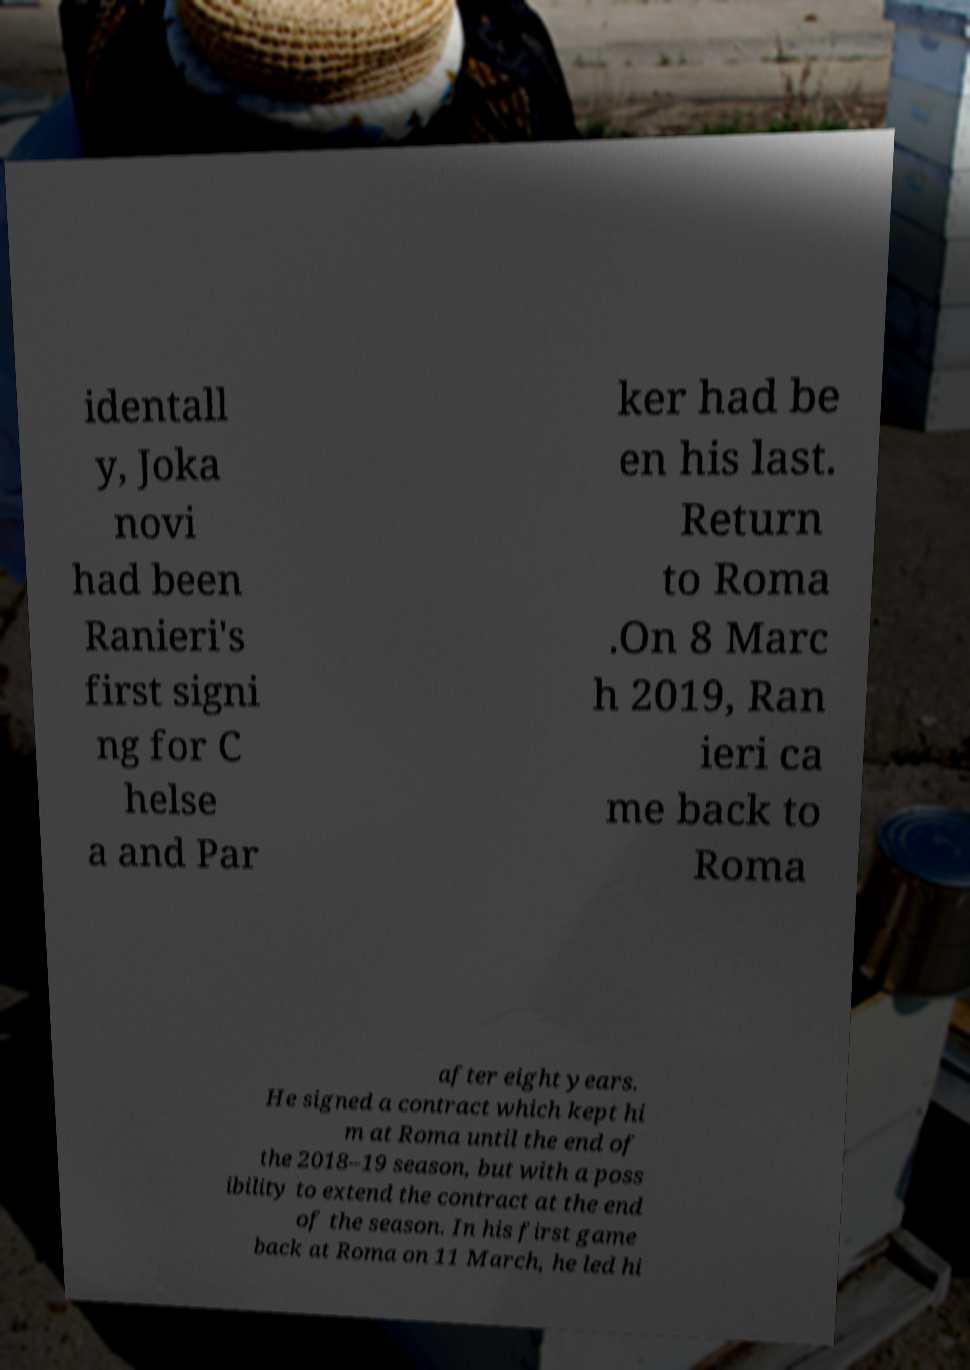Can you accurately transcribe the text from the provided image for me? identall y, Joka novi had been Ranieri's first signi ng for C helse a and Par ker had be en his last. Return to Roma .On 8 Marc h 2019, Ran ieri ca me back to Roma after eight years. He signed a contract which kept hi m at Roma until the end of the 2018–19 season, but with a poss ibility to extend the contract at the end of the season. In his first game back at Roma on 11 March, he led hi 